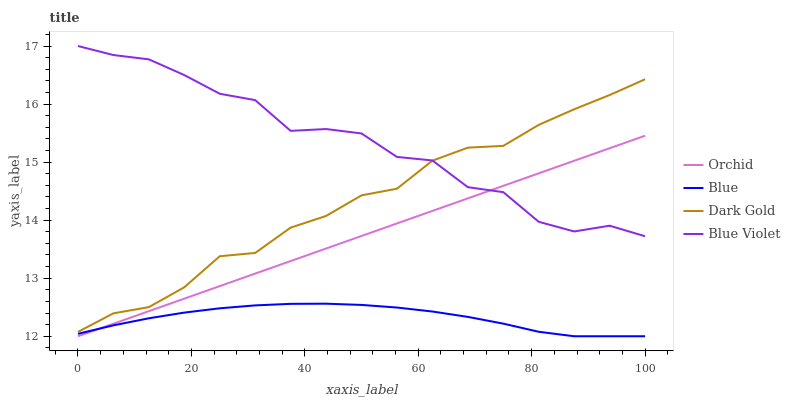Does Dark Gold have the minimum area under the curve?
Answer yes or no. No. Does Dark Gold have the maximum area under the curve?
Answer yes or no. No. Is Dark Gold the smoothest?
Answer yes or no. No. Is Dark Gold the roughest?
Answer yes or no. No. Does Dark Gold have the lowest value?
Answer yes or no. No. Does Dark Gold have the highest value?
Answer yes or no. No. Is Blue less than Blue Violet?
Answer yes or no. Yes. Is Blue Violet greater than Blue?
Answer yes or no. Yes. Does Blue intersect Blue Violet?
Answer yes or no. No. 